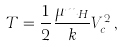<formula> <loc_0><loc_0><loc_500><loc_500>T = \frac { 1 } { 2 } \frac { \mu m _ { H } } { k } V _ { c } ^ { 2 } \, ,</formula> 